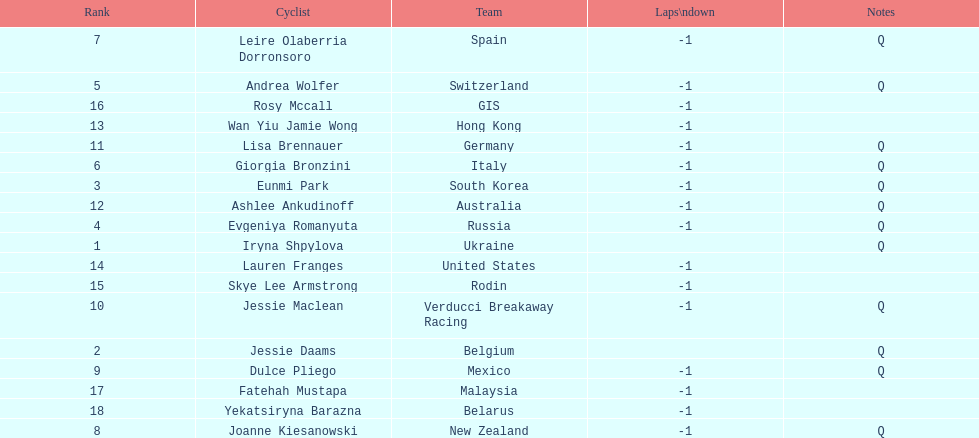How many consecutive notes are there? 12. 